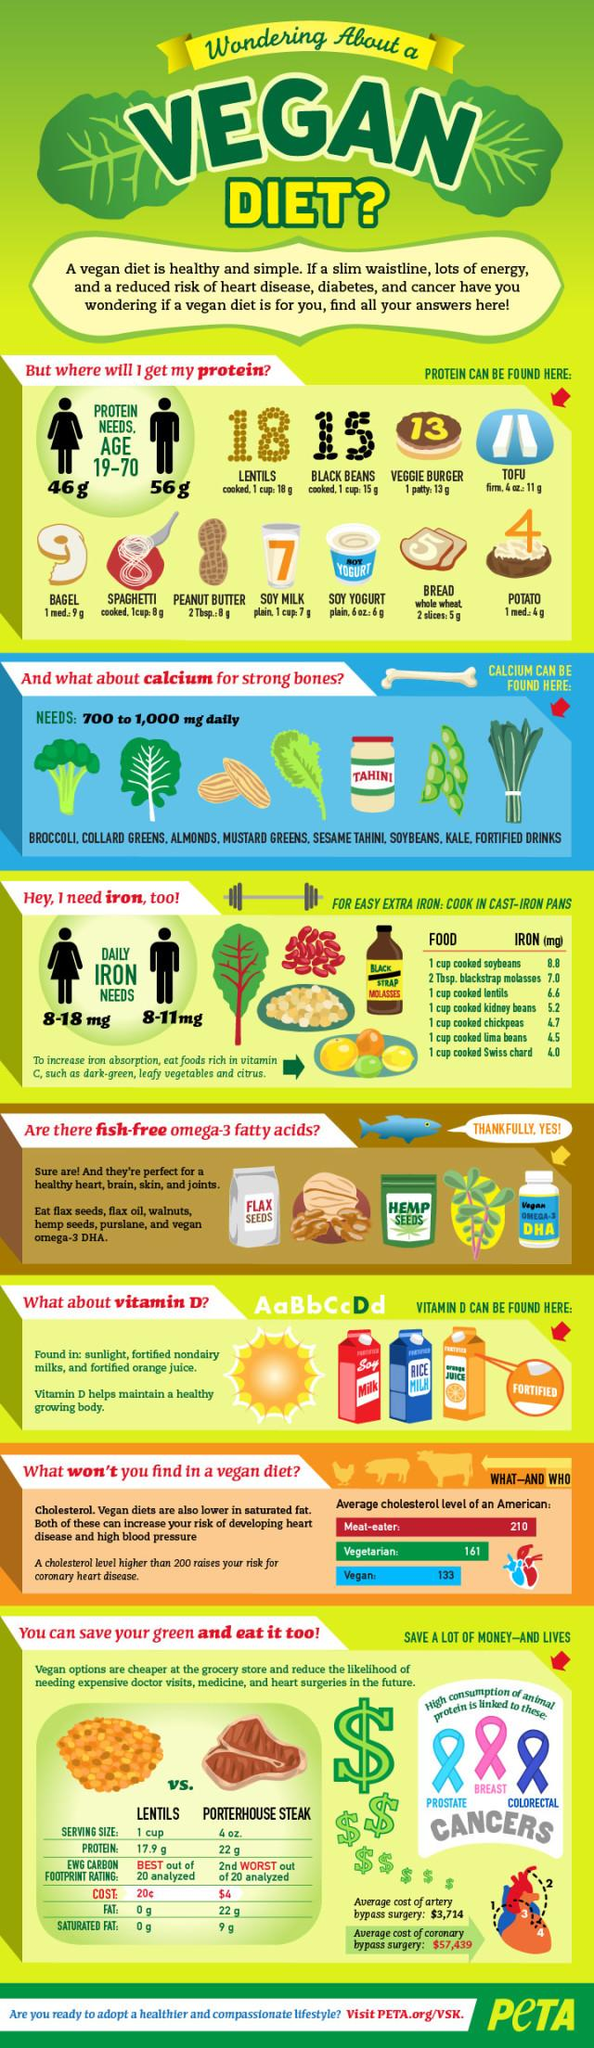Indicate a few pertinent items in this graphic. Swiss chard is a vegetable that provides iron, a crucial nutrient for the human body. Lentils provide the highest amount of protein among the listed food items. There are 6 items listed that can be used as an alternative to fish omega-3 fatty acids. The recommended daily intake of calcium is between 700 and 1,000 milligrams per day. Vegans, a group of Americans, have the lowest average cholesterol level compared to other groups in the United States. 